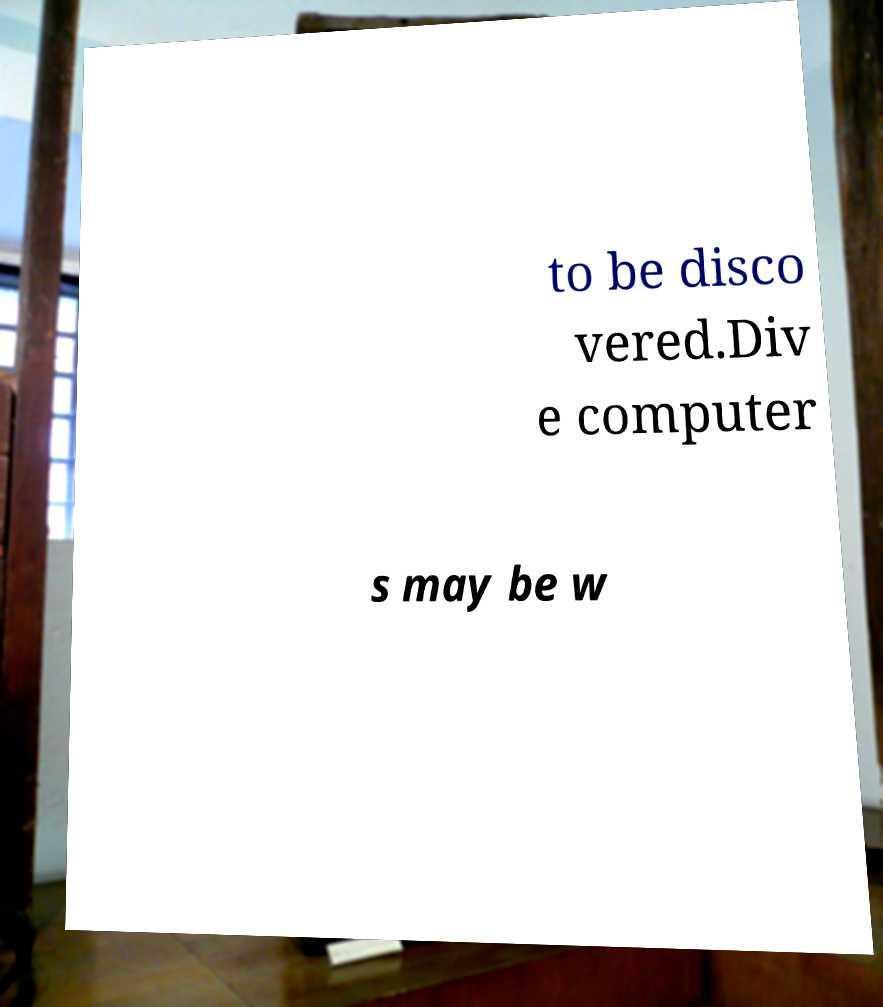There's text embedded in this image that I need extracted. Can you transcribe it verbatim? to be disco vered.Div e computer s may be w 